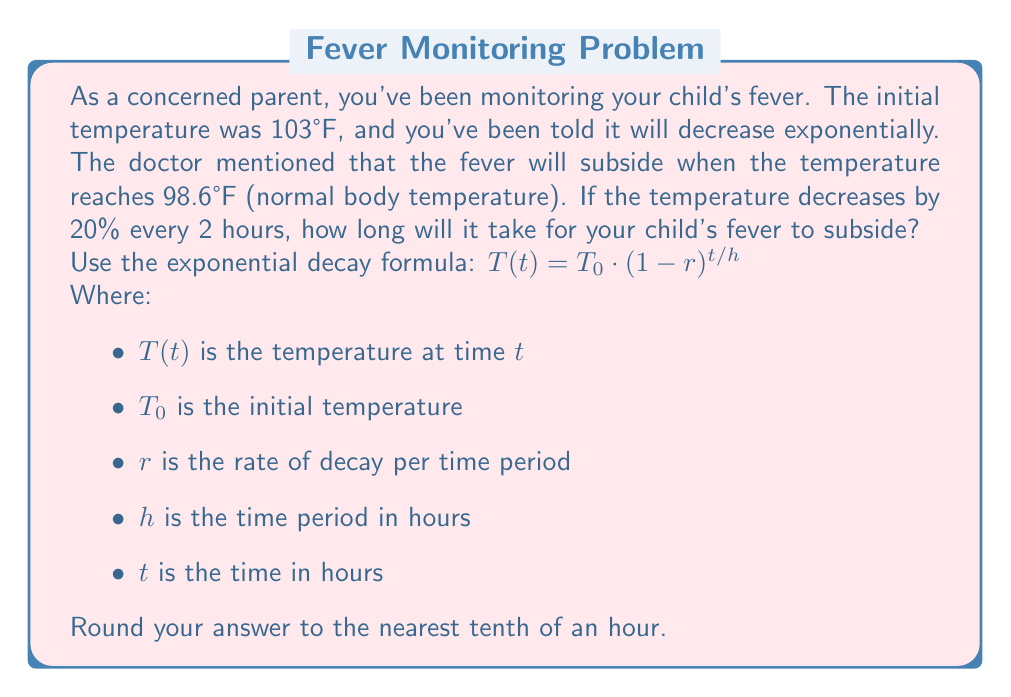What is the answer to this math problem? Let's approach this step-by-step:

1) We're given:
   $T_0 = 103°F$ (initial temperature)
   $T(t) = 98.6°F$ (final temperature)
   $r = 0.20$ (20% decrease every 2 hours)
   $h = 2$ hours (time period)

2) We need to solve for $t$ in the exponential decay formula:
   $T(t) = T_0 \cdot (1-r)^{t/h}$

3) Substituting our known values:
   $98.6 = 103 \cdot (1-0.20)^{t/2}$

4) Simplify:
   $98.6 = 103 \cdot (0.8)^{t/2}$

5) Divide both sides by 103:
   $\frac{98.6}{103} = (0.8)^{t/2}$

6) Take the natural log of both sides:
   $\ln(\frac{98.6}{103}) = \ln((0.8)^{t/2})$

7) Use the logarithm property $\ln(x^n) = n\ln(x)$:
   $\ln(\frac{98.6}{103}) = \frac{t}{2}\ln(0.8)$

8) Solve for $t$:
   $t = \frac{2\ln(\frac{98.6}{103})}{\ln(0.8)}$

9) Calculate:
   $t \approx 5.36$ hours

10) Rounding to the nearest tenth:
    $t \approx 5.4$ hours
Answer: It will take approximately 5.4 hours for the child's fever to subside. 